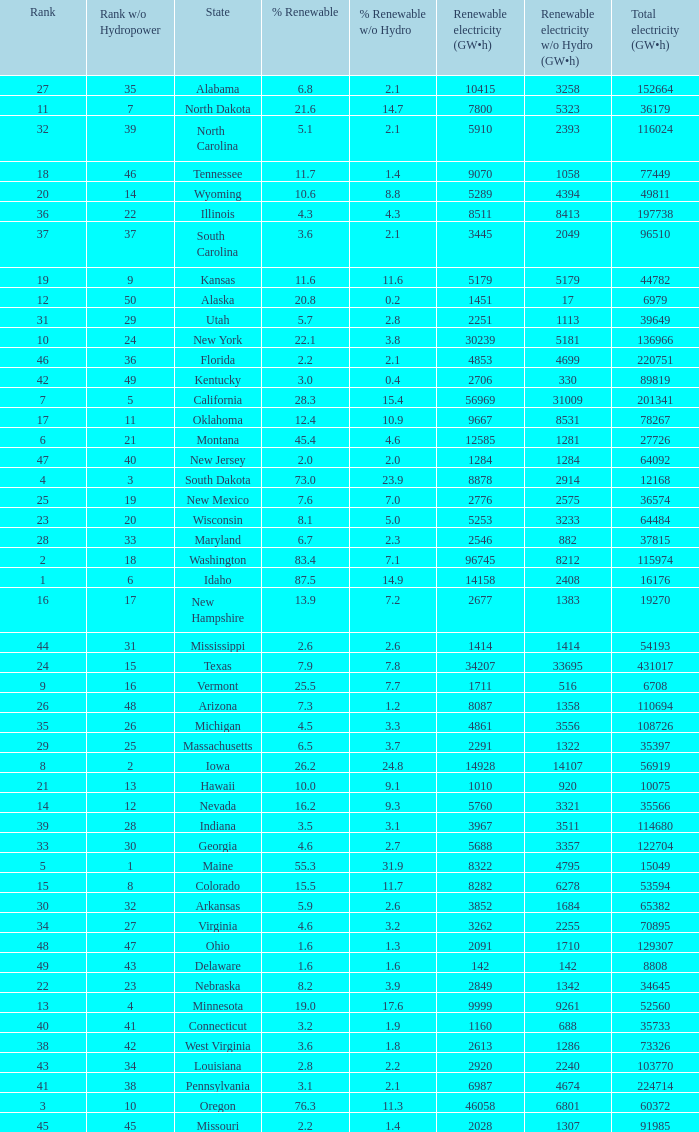Which states have renewable electricity equal to 9667 (gw×h)? Oklahoma. 